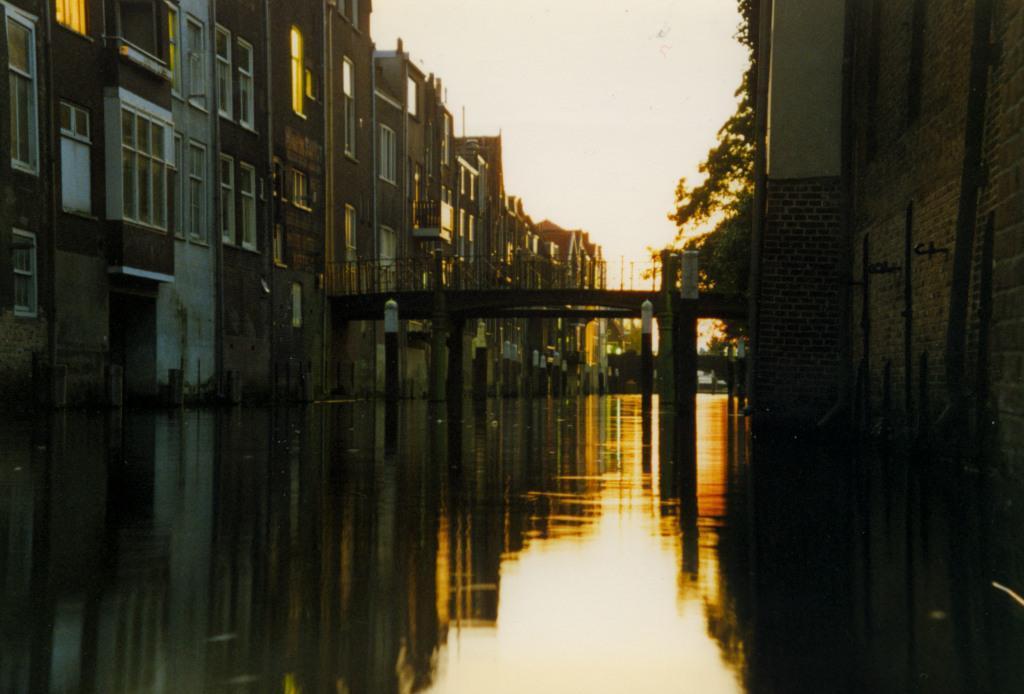Describe this image in one or two sentences. In this image there is the sky towards the top of the image, there are houses towards the left of the image, there are windows, there is a bridge, there are pillars, there is water towards the bottom of the image, there is a tree towards the right of the image, there is the wall towards the right of the image. 